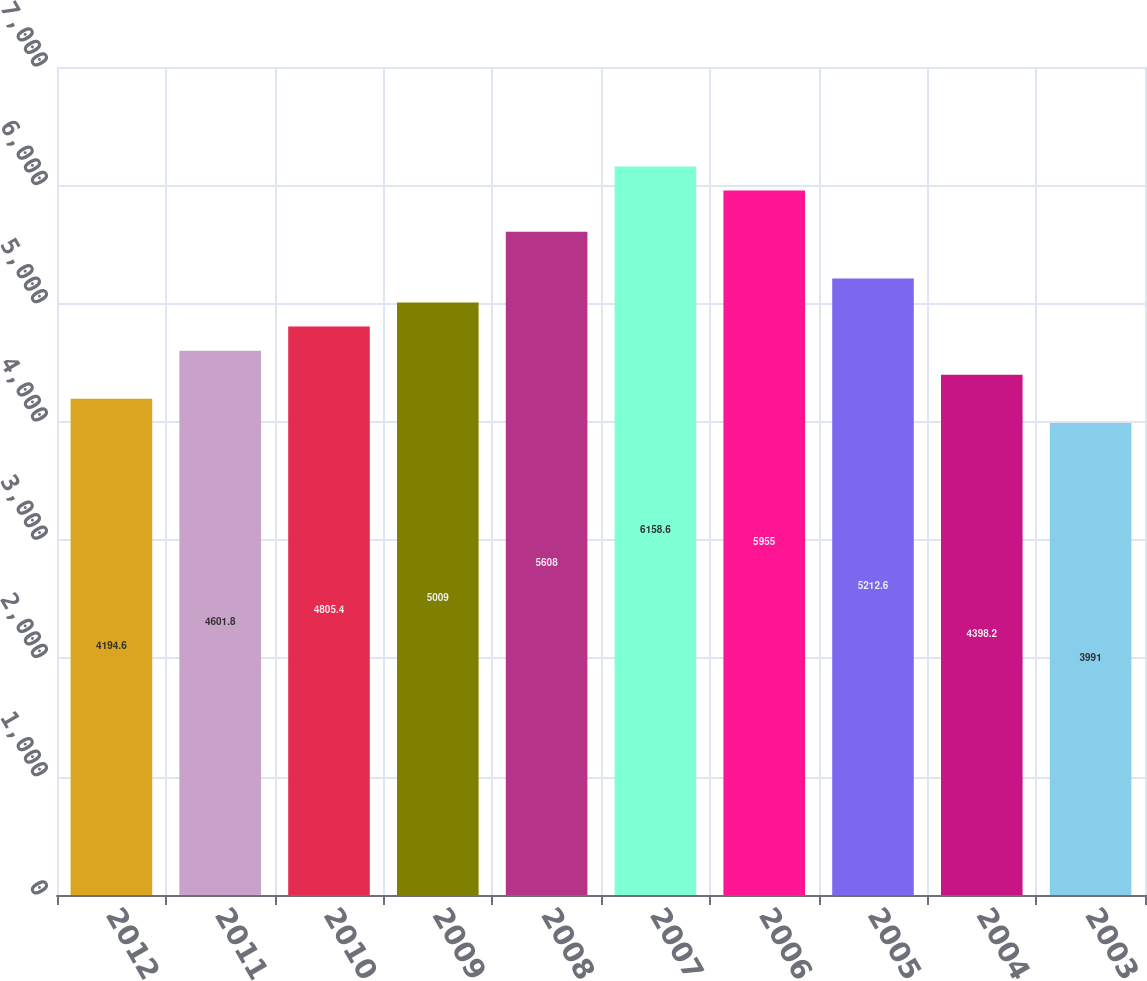Convert chart. <chart><loc_0><loc_0><loc_500><loc_500><bar_chart><fcel>2012<fcel>2011<fcel>2010<fcel>2009<fcel>2008<fcel>2007<fcel>2006<fcel>2005<fcel>2004<fcel>2003<nl><fcel>4194.6<fcel>4601.8<fcel>4805.4<fcel>5009<fcel>5608<fcel>6158.6<fcel>5955<fcel>5212.6<fcel>4398.2<fcel>3991<nl></chart> 